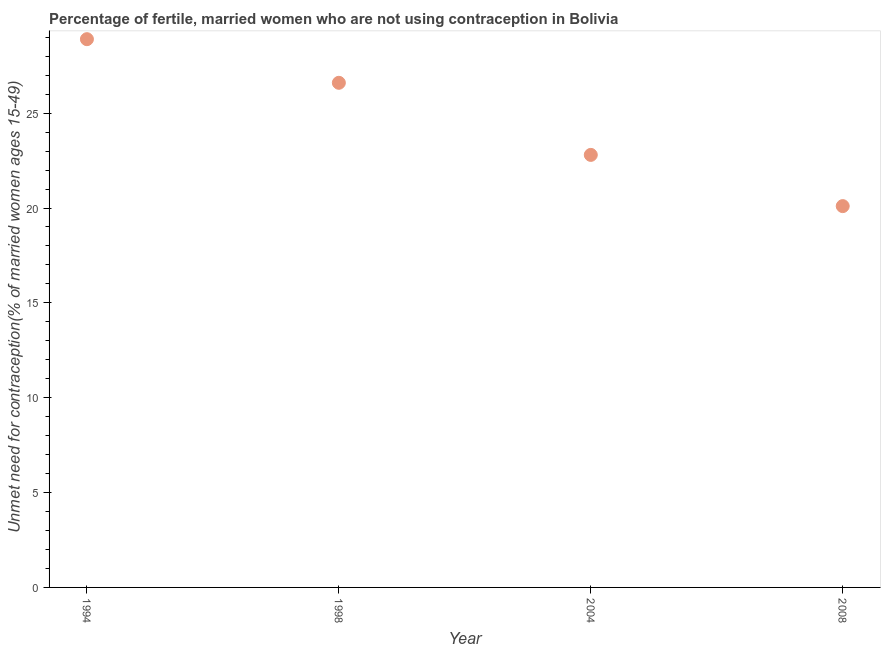What is the number of married women who are not using contraception in 2004?
Ensure brevity in your answer.  22.8. Across all years, what is the maximum number of married women who are not using contraception?
Keep it short and to the point. 28.9. Across all years, what is the minimum number of married women who are not using contraception?
Offer a very short reply. 20.1. In which year was the number of married women who are not using contraception maximum?
Keep it short and to the point. 1994. In which year was the number of married women who are not using contraception minimum?
Give a very brief answer. 2008. What is the sum of the number of married women who are not using contraception?
Keep it short and to the point. 98.4. What is the difference between the number of married women who are not using contraception in 1994 and 2004?
Your answer should be very brief. 6.1. What is the average number of married women who are not using contraception per year?
Give a very brief answer. 24.6. What is the median number of married women who are not using contraception?
Make the answer very short. 24.7. In how many years, is the number of married women who are not using contraception greater than 6 %?
Provide a succinct answer. 4. What is the ratio of the number of married women who are not using contraception in 2004 to that in 2008?
Ensure brevity in your answer.  1.13. Is the number of married women who are not using contraception in 2004 less than that in 2008?
Keep it short and to the point. No. What is the difference between the highest and the second highest number of married women who are not using contraception?
Offer a very short reply. 2.3. Is the sum of the number of married women who are not using contraception in 1994 and 2004 greater than the maximum number of married women who are not using contraception across all years?
Your response must be concise. Yes. What is the difference between the highest and the lowest number of married women who are not using contraception?
Make the answer very short. 8.8. In how many years, is the number of married women who are not using contraception greater than the average number of married women who are not using contraception taken over all years?
Offer a terse response. 2. Does the graph contain any zero values?
Provide a succinct answer. No. What is the title of the graph?
Ensure brevity in your answer.  Percentage of fertile, married women who are not using contraception in Bolivia. What is the label or title of the X-axis?
Give a very brief answer. Year. What is the label or title of the Y-axis?
Keep it short and to the point.  Unmet need for contraception(% of married women ages 15-49). What is the  Unmet need for contraception(% of married women ages 15-49) in 1994?
Ensure brevity in your answer.  28.9. What is the  Unmet need for contraception(% of married women ages 15-49) in 1998?
Ensure brevity in your answer.  26.6. What is the  Unmet need for contraception(% of married women ages 15-49) in 2004?
Keep it short and to the point. 22.8. What is the  Unmet need for contraception(% of married women ages 15-49) in 2008?
Give a very brief answer. 20.1. What is the difference between the  Unmet need for contraception(% of married women ages 15-49) in 1994 and 2008?
Offer a very short reply. 8.8. What is the difference between the  Unmet need for contraception(% of married women ages 15-49) in 2004 and 2008?
Your answer should be very brief. 2.7. What is the ratio of the  Unmet need for contraception(% of married women ages 15-49) in 1994 to that in 1998?
Offer a terse response. 1.09. What is the ratio of the  Unmet need for contraception(% of married women ages 15-49) in 1994 to that in 2004?
Ensure brevity in your answer.  1.27. What is the ratio of the  Unmet need for contraception(% of married women ages 15-49) in 1994 to that in 2008?
Your response must be concise. 1.44. What is the ratio of the  Unmet need for contraception(% of married women ages 15-49) in 1998 to that in 2004?
Offer a terse response. 1.17. What is the ratio of the  Unmet need for contraception(% of married women ages 15-49) in 1998 to that in 2008?
Provide a succinct answer. 1.32. What is the ratio of the  Unmet need for contraception(% of married women ages 15-49) in 2004 to that in 2008?
Give a very brief answer. 1.13. 